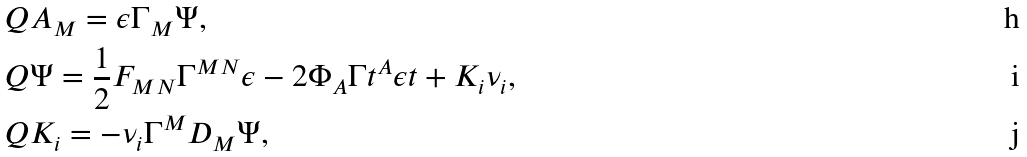<formula> <loc_0><loc_0><loc_500><loc_500>& Q A _ { M } = \epsilon \Gamma _ { M } \Psi , \\ & Q \Psi = \frac { 1 } { 2 } F _ { M N } \Gamma ^ { M N } \epsilon - 2 \Phi _ { A } \Gamma t ^ { A } \epsilon t + K _ { i } \nu _ { i } , \\ & Q K _ { i } = - \nu _ { i } \Gamma ^ { M } D _ { M } \Psi ,</formula> 